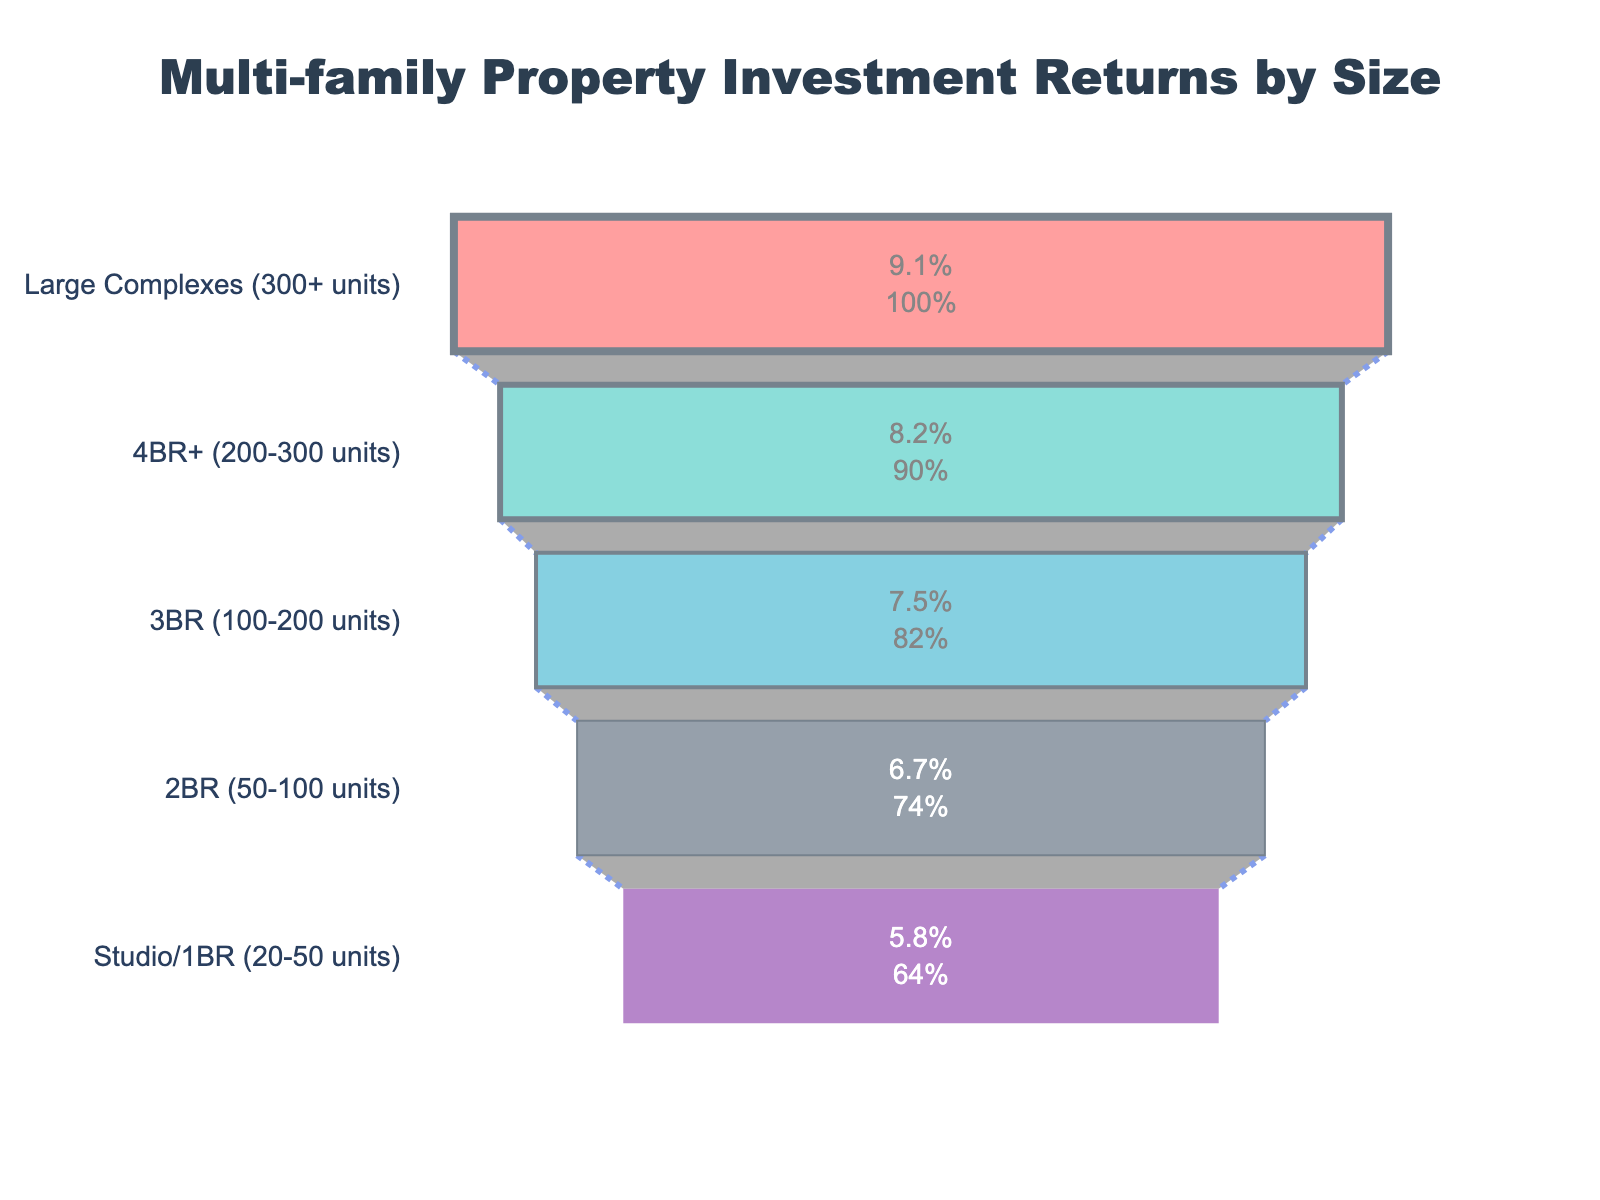What is the property size with the highest average annual return? The property size with the highest average annual return can be identified by looking at the top segment of the funnel chart. The topmost segment represents the property size with the highest return.
Answer: Large Complexes (300+ units) What is the average annual return for 2BR (50-100 units) properties? By referring to its corresponding segment in the funnel chart, we can see the value displayed for 2BR (50-100 units).
Answer: 6.7% How does the average annual return of 3BR (100-200 units) compare to that of Studio/1BR (20-50 units)? The funnel segments show that 3BR (100-200 units) has a return of 7.5%, whereas Studio/1BR (20-50 units) has a return of 5.8%. By comparing these values, we see that the return for 3BR (100-200 units) is higher.
Answer: 3BR (100-200 units) has a higher return What is the difference in average annual return between the smallest and largest property sizes? Identify and subtract the values from the top and bottom segments of the funnel chart. The smallest property size is Studio/1BR (20-50 units) with 5.8% and the largest is Large Complexes (300+ units) with 9.1%. So, 9.1% - 5.8% = 3.3%.
Answer: 3.3% How many different property sizes are represented in the funnel chart? Count the number of segments in the funnel chart.
Answer: 5 What percentage increase in average annual return is observed when moving from 4BR+ (200-300 units) to Large Complexes (300+ units)? The returns are 8.2% for 4BR+ (200-300 units) and 9.1% for Large Complexes (300+ units). Calculate the percentage increase: (9.1 - 8.2) / 8.2 * 100% ≈ 10.98%.
Answer: 10.98% Which property size shows a higher return, 2BR (50-100 units) or 4BR+ (200-300 units)? By comparing the segments for these property sizes, 2BR (50-100 units) has a return of 6.7% and 4BR+ (200-300 units) has a return of 8.2%. Thus, 4BR+ (200-300 units) is higher.
Answer: 4BR+ (200-300 units) What is the combined average annual return of properties with fewer than 100 units? Identify the segments corresponding to these property sizes: Studio/1BR (20-50 units) at 5.8% and 2BR (50-100 units) at 6.7%. Add the values to get 5.8% + 6.7% = 12.5%.
Answer: 12.5% Arrange the property sizes in order of their average annual return, from lowest to highest. List the property sizes according to their return values as shown in the funnel chart: Studio/1BR (20-50 units) < 2BR (50-100 units) < 3BR (100-200 units) < 4BR+ (200-300 units) < Large Complexes (300+ units).
Answer: Studio/1BR (20-50 units), 2BR (50-100 units), 3BR (100-200 units), 4BR+ (200-300 units), Large Complexes (300+ units) 